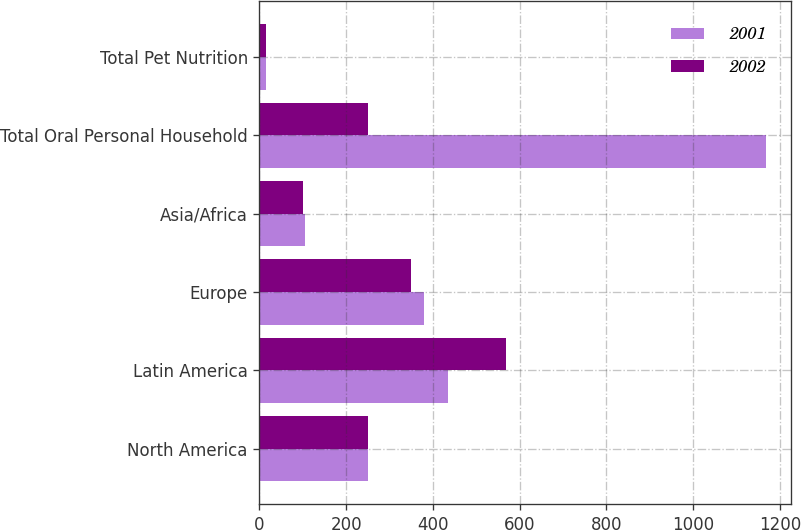Convert chart. <chart><loc_0><loc_0><loc_500><loc_500><stacked_bar_chart><ecel><fcel>North America<fcel>Latin America<fcel>Europe<fcel>Asia/Africa<fcel>Total Oral Personal Household<fcel>Total Pet Nutrition<nl><fcel>2001<fcel>250.1<fcel>433.6<fcel>379.9<fcel>104.2<fcel>1167.8<fcel>15<nl><fcel>2002<fcel>249.6<fcel>568.7<fcel>350.2<fcel>100.7<fcel>250.1<fcel>15<nl></chart> 